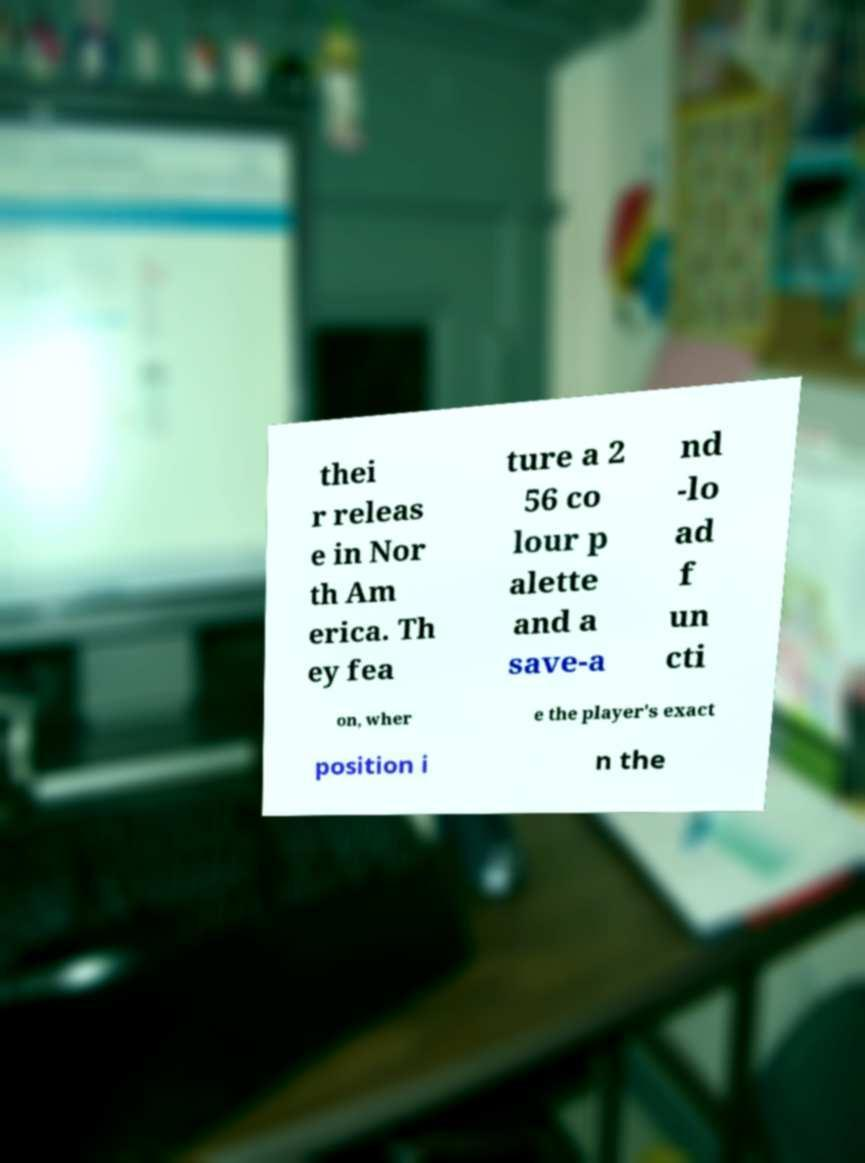Could you extract and type out the text from this image? thei r releas e in Nor th Am erica. Th ey fea ture a 2 56 co lour p alette and a save-a nd -lo ad f un cti on, wher e the player's exact position i n the 